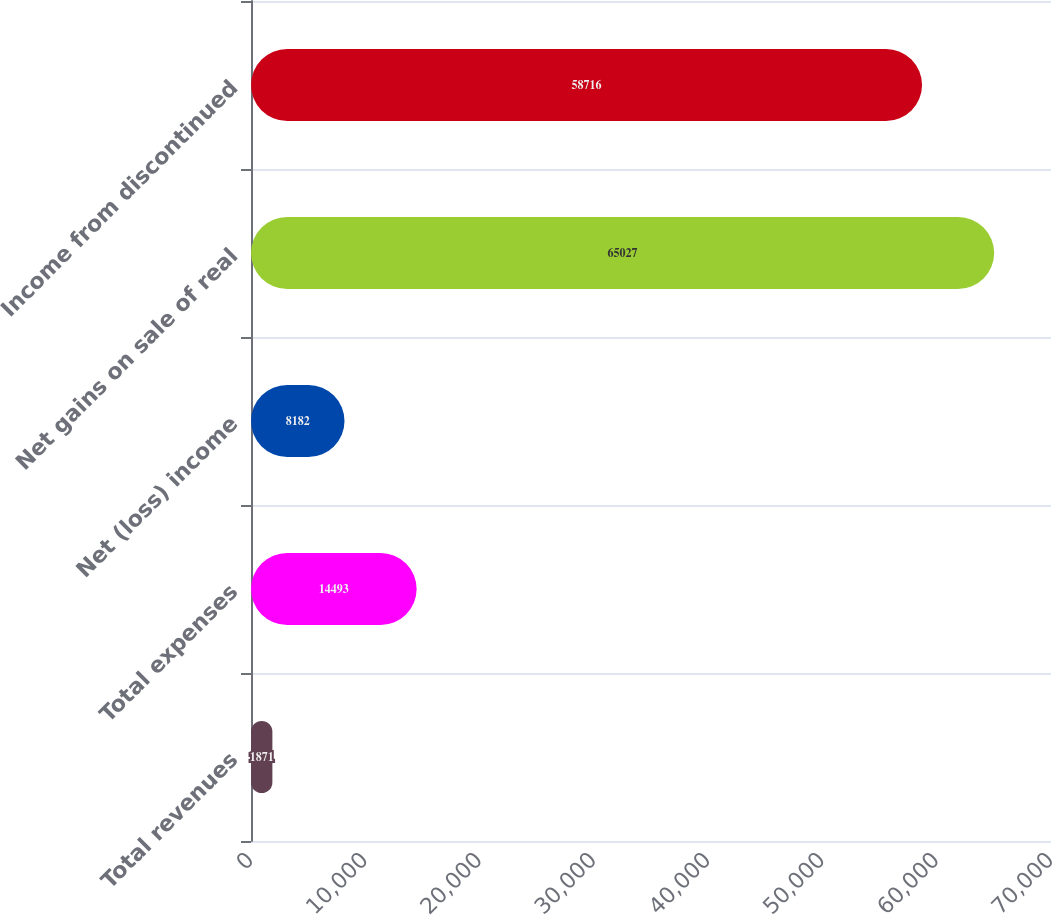Convert chart to OTSL. <chart><loc_0><loc_0><loc_500><loc_500><bar_chart><fcel>Total revenues<fcel>Total expenses<fcel>Net (loss) income<fcel>Net gains on sale of real<fcel>Income from discontinued<nl><fcel>1871<fcel>14493<fcel>8182<fcel>65027<fcel>58716<nl></chart> 